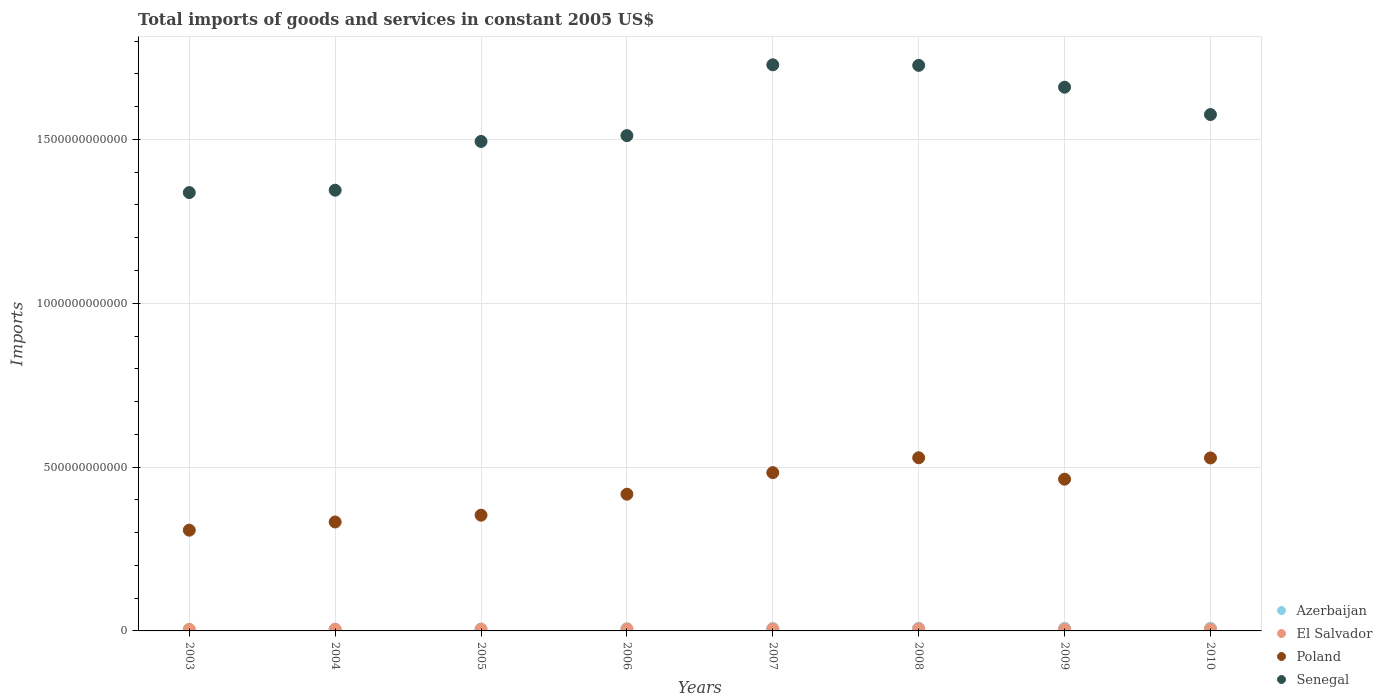How many different coloured dotlines are there?
Your answer should be compact. 4. What is the total imports of goods and services in Senegal in 2004?
Give a very brief answer. 1.35e+12. Across all years, what is the maximum total imports of goods and services in Poland?
Give a very brief answer. 5.28e+11. Across all years, what is the minimum total imports of goods and services in Senegal?
Your response must be concise. 1.34e+12. In which year was the total imports of goods and services in Senegal minimum?
Offer a very short reply. 2003. What is the total total imports of goods and services in El Salvador in the graph?
Provide a short and direct response. 4.37e+1. What is the difference between the total imports of goods and services in Poland in 2008 and that in 2010?
Make the answer very short. 5.69e+08. What is the difference between the total imports of goods and services in Azerbaijan in 2007 and the total imports of goods and services in Senegal in 2010?
Your answer should be compact. -1.57e+12. What is the average total imports of goods and services in Poland per year?
Your answer should be very brief. 4.27e+11. In the year 2007, what is the difference between the total imports of goods and services in Azerbaijan and total imports of goods and services in Senegal?
Provide a short and direct response. -1.72e+12. What is the ratio of the total imports of goods and services in El Salvador in 2007 to that in 2008?
Give a very brief answer. 0.97. Is the total imports of goods and services in Senegal in 2004 less than that in 2007?
Ensure brevity in your answer.  Yes. What is the difference between the highest and the second highest total imports of goods and services in Azerbaijan?
Make the answer very short. 3.33e+08. What is the difference between the highest and the lowest total imports of goods and services in Poland?
Offer a terse response. 2.21e+11. In how many years, is the total imports of goods and services in Poland greater than the average total imports of goods and services in Poland taken over all years?
Provide a succinct answer. 4. Is it the case that in every year, the sum of the total imports of goods and services in El Salvador and total imports of goods and services in Senegal  is greater than the sum of total imports of goods and services in Azerbaijan and total imports of goods and services in Poland?
Your answer should be very brief. No. Does the total imports of goods and services in Azerbaijan monotonically increase over the years?
Provide a short and direct response. No. Is the total imports of goods and services in El Salvador strictly greater than the total imports of goods and services in Senegal over the years?
Give a very brief answer. No. Is the total imports of goods and services in Poland strictly less than the total imports of goods and services in Senegal over the years?
Provide a short and direct response. Yes. How many dotlines are there?
Give a very brief answer. 4. How many years are there in the graph?
Give a very brief answer. 8. What is the difference between two consecutive major ticks on the Y-axis?
Your answer should be compact. 5.00e+11. Are the values on the major ticks of Y-axis written in scientific E-notation?
Ensure brevity in your answer.  No. Does the graph contain any zero values?
Provide a succinct answer. No. What is the title of the graph?
Offer a very short reply. Total imports of goods and services in constant 2005 US$. What is the label or title of the Y-axis?
Your answer should be compact. Imports. What is the Imports in Azerbaijan in 2003?
Ensure brevity in your answer.  4.22e+09. What is the Imports in El Salvador in 2003?
Give a very brief answer. 4.90e+09. What is the Imports in Poland in 2003?
Ensure brevity in your answer.  3.07e+11. What is the Imports of Senegal in 2003?
Your answer should be very brief. 1.34e+12. What is the Imports of Azerbaijan in 2004?
Provide a succinct answer. 5.25e+09. What is the Imports in El Salvador in 2004?
Your response must be concise. 5.03e+09. What is the Imports of Poland in 2004?
Keep it short and to the point. 3.32e+11. What is the Imports in Senegal in 2004?
Your answer should be compact. 1.35e+12. What is the Imports of Azerbaijan in 2005?
Provide a short and direct response. 5.74e+09. What is the Imports in El Salvador in 2005?
Your answer should be very brief. 5.24e+09. What is the Imports in Poland in 2005?
Offer a terse response. 3.53e+11. What is the Imports of Senegal in 2005?
Your response must be concise. 1.49e+12. What is the Imports of Azerbaijan in 2006?
Offer a very short reply. 6.59e+09. What is the Imports of El Salvador in 2006?
Keep it short and to the point. 5.71e+09. What is the Imports of Poland in 2006?
Your answer should be very brief. 4.17e+11. What is the Imports of Senegal in 2006?
Offer a very short reply. 1.51e+12. What is the Imports in Azerbaijan in 2007?
Your response must be concise. 7.29e+09. What is the Imports of El Salvador in 2007?
Provide a short and direct response. 6.21e+09. What is the Imports in Poland in 2007?
Offer a very short reply. 4.83e+11. What is the Imports of Senegal in 2007?
Give a very brief answer. 1.73e+12. What is the Imports of Azerbaijan in 2008?
Provide a succinct answer. 8.33e+09. What is the Imports of El Salvador in 2008?
Your answer should be very brief. 6.42e+09. What is the Imports in Poland in 2008?
Your answer should be very brief. 5.28e+11. What is the Imports of Senegal in 2008?
Offer a terse response. 1.73e+12. What is the Imports in Azerbaijan in 2009?
Provide a succinct answer. 7.89e+09. What is the Imports in El Salvador in 2009?
Your response must be concise. 4.83e+09. What is the Imports of Poland in 2009?
Your answer should be very brief. 4.63e+11. What is the Imports in Senegal in 2009?
Provide a succinct answer. 1.66e+12. What is the Imports of Azerbaijan in 2010?
Provide a short and direct response. 8.00e+09. What is the Imports of El Salvador in 2010?
Ensure brevity in your answer.  5.33e+09. What is the Imports of Poland in 2010?
Make the answer very short. 5.28e+11. What is the Imports of Senegal in 2010?
Your answer should be very brief. 1.58e+12. Across all years, what is the maximum Imports in Azerbaijan?
Your response must be concise. 8.33e+09. Across all years, what is the maximum Imports of El Salvador?
Your answer should be compact. 6.42e+09. Across all years, what is the maximum Imports in Poland?
Ensure brevity in your answer.  5.28e+11. Across all years, what is the maximum Imports in Senegal?
Provide a succinct answer. 1.73e+12. Across all years, what is the minimum Imports of Azerbaijan?
Keep it short and to the point. 4.22e+09. Across all years, what is the minimum Imports in El Salvador?
Offer a very short reply. 4.83e+09. Across all years, what is the minimum Imports of Poland?
Your response must be concise. 3.07e+11. Across all years, what is the minimum Imports of Senegal?
Your response must be concise. 1.34e+12. What is the total Imports in Azerbaijan in the graph?
Offer a very short reply. 5.33e+1. What is the total Imports in El Salvador in the graph?
Your answer should be compact. 4.37e+1. What is the total Imports in Poland in the graph?
Offer a very short reply. 3.41e+12. What is the total Imports in Senegal in the graph?
Ensure brevity in your answer.  1.24e+13. What is the difference between the Imports in Azerbaijan in 2003 and that in 2004?
Make the answer very short. -1.02e+09. What is the difference between the Imports in El Salvador in 2003 and that in 2004?
Your answer should be compact. -1.27e+08. What is the difference between the Imports of Poland in 2003 and that in 2004?
Offer a terse response. -2.50e+1. What is the difference between the Imports of Senegal in 2003 and that in 2004?
Provide a short and direct response. -7.19e+09. What is the difference between the Imports of Azerbaijan in 2003 and that in 2005?
Your answer should be compact. -1.52e+09. What is the difference between the Imports of El Salvador in 2003 and that in 2005?
Keep it short and to the point. -3.45e+08. What is the difference between the Imports in Poland in 2003 and that in 2005?
Offer a very short reply. -4.58e+1. What is the difference between the Imports of Senegal in 2003 and that in 2005?
Provide a short and direct response. -1.56e+11. What is the difference between the Imports of Azerbaijan in 2003 and that in 2006?
Give a very brief answer. -2.37e+09. What is the difference between the Imports of El Salvador in 2003 and that in 2006?
Ensure brevity in your answer.  -8.12e+08. What is the difference between the Imports of Poland in 2003 and that in 2006?
Your answer should be very brief. -1.10e+11. What is the difference between the Imports of Senegal in 2003 and that in 2006?
Give a very brief answer. -1.74e+11. What is the difference between the Imports of Azerbaijan in 2003 and that in 2007?
Your answer should be compact. -3.07e+09. What is the difference between the Imports in El Salvador in 2003 and that in 2007?
Give a very brief answer. -1.32e+09. What is the difference between the Imports in Poland in 2003 and that in 2007?
Your answer should be very brief. -1.76e+11. What is the difference between the Imports in Senegal in 2003 and that in 2007?
Offer a very short reply. -3.90e+11. What is the difference between the Imports of Azerbaijan in 2003 and that in 2008?
Give a very brief answer. -4.11e+09. What is the difference between the Imports of El Salvador in 2003 and that in 2008?
Offer a very short reply. -1.52e+09. What is the difference between the Imports of Poland in 2003 and that in 2008?
Offer a terse response. -2.21e+11. What is the difference between the Imports of Senegal in 2003 and that in 2008?
Your answer should be compact. -3.88e+11. What is the difference between the Imports of Azerbaijan in 2003 and that in 2009?
Keep it short and to the point. -3.67e+09. What is the difference between the Imports in El Salvador in 2003 and that in 2009?
Provide a succinct answer. 7.39e+07. What is the difference between the Imports in Poland in 2003 and that in 2009?
Ensure brevity in your answer.  -1.56e+11. What is the difference between the Imports of Senegal in 2003 and that in 2009?
Give a very brief answer. -3.22e+11. What is the difference between the Imports in Azerbaijan in 2003 and that in 2010?
Make the answer very short. -3.78e+09. What is the difference between the Imports of El Salvador in 2003 and that in 2010?
Provide a short and direct response. -4.29e+08. What is the difference between the Imports in Poland in 2003 and that in 2010?
Provide a succinct answer. -2.20e+11. What is the difference between the Imports of Senegal in 2003 and that in 2010?
Your answer should be very brief. -2.38e+11. What is the difference between the Imports in Azerbaijan in 2004 and that in 2005?
Your answer should be very brief. -4.96e+08. What is the difference between the Imports of El Salvador in 2004 and that in 2005?
Your answer should be very brief. -2.18e+08. What is the difference between the Imports of Poland in 2004 and that in 2005?
Give a very brief answer. -2.08e+1. What is the difference between the Imports in Senegal in 2004 and that in 2005?
Give a very brief answer. -1.49e+11. What is the difference between the Imports in Azerbaijan in 2004 and that in 2006?
Keep it short and to the point. -1.34e+09. What is the difference between the Imports of El Salvador in 2004 and that in 2006?
Your response must be concise. -6.86e+08. What is the difference between the Imports of Poland in 2004 and that in 2006?
Your answer should be compact. -8.48e+1. What is the difference between the Imports of Senegal in 2004 and that in 2006?
Provide a succinct answer. -1.67e+11. What is the difference between the Imports of Azerbaijan in 2004 and that in 2007?
Give a very brief answer. -2.04e+09. What is the difference between the Imports in El Salvador in 2004 and that in 2007?
Offer a terse response. -1.19e+09. What is the difference between the Imports in Poland in 2004 and that in 2007?
Give a very brief answer. -1.51e+11. What is the difference between the Imports of Senegal in 2004 and that in 2007?
Your answer should be very brief. -3.83e+11. What is the difference between the Imports of Azerbaijan in 2004 and that in 2008?
Provide a succinct answer. -3.09e+09. What is the difference between the Imports of El Salvador in 2004 and that in 2008?
Provide a short and direct response. -1.39e+09. What is the difference between the Imports in Poland in 2004 and that in 2008?
Provide a succinct answer. -1.96e+11. What is the difference between the Imports of Senegal in 2004 and that in 2008?
Ensure brevity in your answer.  -3.81e+11. What is the difference between the Imports of Azerbaijan in 2004 and that in 2009?
Your answer should be compact. -2.65e+09. What is the difference between the Imports of El Salvador in 2004 and that in 2009?
Offer a very short reply. 2.01e+08. What is the difference between the Imports in Poland in 2004 and that in 2009?
Your response must be concise. -1.31e+11. What is the difference between the Imports of Senegal in 2004 and that in 2009?
Offer a terse response. -3.14e+11. What is the difference between the Imports in Azerbaijan in 2004 and that in 2010?
Your answer should be very brief. -2.76e+09. What is the difference between the Imports of El Salvador in 2004 and that in 2010?
Offer a terse response. -3.02e+08. What is the difference between the Imports of Poland in 2004 and that in 2010?
Make the answer very short. -1.95e+11. What is the difference between the Imports of Senegal in 2004 and that in 2010?
Keep it short and to the point. -2.31e+11. What is the difference between the Imports in Azerbaijan in 2005 and that in 2006?
Provide a short and direct response. -8.46e+08. What is the difference between the Imports in El Salvador in 2005 and that in 2006?
Make the answer very short. -4.68e+08. What is the difference between the Imports of Poland in 2005 and that in 2006?
Your answer should be very brief. -6.40e+1. What is the difference between the Imports in Senegal in 2005 and that in 2006?
Your answer should be compact. -1.78e+1. What is the difference between the Imports in Azerbaijan in 2005 and that in 2007?
Your answer should be very brief. -1.55e+09. What is the difference between the Imports of El Salvador in 2005 and that in 2007?
Offer a terse response. -9.70e+08. What is the difference between the Imports of Poland in 2005 and that in 2007?
Your answer should be very brief. -1.30e+11. What is the difference between the Imports of Senegal in 2005 and that in 2007?
Ensure brevity in your answer.  -2.34e+11. What is the difference between the Imports in Azerbaijan in 2005 and that in 2008?
Keep it short and to the point. -2.59e+09. What is the difference between the Imports in El Salvador in 2005 and that in 2008?
Your response must be concise. -1.17e+09. What is the difference between the Imports of Poland in 2005 and that in 2008?
Offer a terse response. -1.75e+11. What is the difference between the Imports of Senegal in 2005 and that in 2008?
Offer a very short reply. -2.32e+11. What is the difference between the Imports of Azerbaijan in 2005 and that in 2009?
Your answer should be very brief. -2.15e+09. What is the difference between the Imports in El Salvador in 2005 and that in 2009?
Your answer should be compact. 4.19e+08. What is the difference between the Imports in Poland in 2005 and that in 2009?
Provide a short and direct response. -1.10e+11. What is the difference between the Imports in Senegal in 2005 and that in 2009?
Make the answer very short. -1.66e+11. What is the difference between the Imports of Azerbaijan in 2005 and that in 2010?
Make the answer very short. -2.26e+09. What is the difference between the Imports in El Salvador in 2005 and that in 2010?
Your response must be concise. -8.42e+07. What is the difference between the Imports in Poland in 2005 and that in 2010?
Your answer should be very brief. -1.75e+11. What is the difference between the Imports in Senegal in 2005 and that in 2010?
Offer a very short reply. -8.21e+1. What is the difference between the Imports of Azerbaijan in 2006 and that in 2007?
Provide a succinct answer. -7.02e+08. What is the difference between the Imports of El Salvador in 2006 and that in 2007?
Provide a succinct answer. -5.03e+08. What is the difference between the Imports of Poland in 2006 and that in 2007?
Your answer should be compact. -6.59e+1. What is the difference between the Imports of Senegal in 2006 and that in 2007?
Give a very brief answer. -2.16e+11. What is the difference between the Imports of Azerbaijan in 2006 and that in 2008?
Offer a very short reply. -1.75e+09. What is the difference between the Imports in El Salvador in 2006 and that in 2008?
Keep it short and to the point. -7.07e+08. What is the difference between the Imports in Poland in 2006 and that in 2008?
Make the answer very short. -1.11e+11. What is the difference between the Imports in Senegal in 2006 and that in 2008?
Offer a terse response. -2.14e+11. What is the difference between the Imports in Azerbaijan in 2006 and that in 2009?
Offer a very short reply. -1.31e+09. What is the difference between the Imports in El Salvador in 2006 and that in 2009?
Provide a succinct answer. 8.86e+08. What is the difference between the Imports of Poland in 2006 and that in 2009?
Offer a very short reply. -4.58e+1. What is the difference between the Imports in Senegal in 2006 and that in 2009?
Provide a short and direct response. -1.48e+11. What is the difference between the Imports of Azerbaijan in 2006 and that in 2010?
Your answer should be compact. -1.41e+09. What is the difference between the Imports of El Salvador in 2006 and that in 2010?
Give a very brief answer. 3.83e+08. What is the difference between the Imports in Poland in 2006 and that in 2010?
Your response must be concise. -1.11e+11. What is the difference between the Imports in Senegal in 2006 and that in 2010?
Make the answer very short. -6.43e+1. What is the difference between the Imports of Azerbaijan in 2007 and that in 2008?
Your answer should be very brief. -1.04e+09. What is the difference between the Imports in El Salvador in 2007 and that in 2008?
Your answer should be compact. -2.04e+08. What is the difference between the Imports of Poland in 2007 and that in 2008?
Provide a short and direct response. -4.53e+1. What is the difference between the Imports in Senegal in 2007 and that in 2008?
Your answer should be very brief. 1.72e+09. What is the difference between the Imports in Azerbaijan in 2007 and that in 2009?
Give a very brief answer. -6.05e+08. What is the difference between the Imports in El Salvador in 2007 and that in 2009?
Your answer should be very brief. 1.39e+09. What is the difference between the Imports in Poland in 2007 and that in 2009?
Your response must be concise. 2.01e+1. What is the difference between the Imports in Senegal in 2007 and that in 2009?
Ensure brevity in your answer.  6.83e+1. What is the difference between the Imports in Azerbaijan in 2007 and that in 2010?
Provide a succinct answer. -7.11e+08. What is the difference between the Imports in El Salvador in 2007 and that in 2010?
Your response must be concise. 8.86e+08. What is the difference between the Imports of Poland in 2007 and that in 2010?
Your response must be concise. -4.48e+1. What is the difference between the Imports in Senegal in 2007 and that in 2010?
Provide a short and direct response. 1.52e+11. What is the difference between the Imports of Azerbaijan in 2008 and that in 2009?
Ensure brevity in your answer.  4.40e+08. What is the difference between the Imports in El Salvador in 2008 and that in 2009?
Your answer should be very brief. 1.59e+09. What is the difference between the Imports in Poland in 2008 and that in 2009?
Ensure brevity in your answer.  6.54e+1. What is the difference between the Imports of Senegal in 2008 and that in 2009?
Provide a short and direct response. 6.66e+1. What is the difference between the Imports in Azerbaijan in 2008 and that in 2010?
Your response must be concise. 3.33e+08. What is the difference between the Imports in El Salvador in 2008 and that in 2010?
Your answer should be very brief. 1.09e+09. What is the difference between the Imports in Poland in 2008 and that in 2010?
Keep it short and to the point. 5.69e+08. What is the difference between the Imports in Senegal in 2008 and that in 2010?
Keep it short and to the point. 1.50e+11. What is the difference between the Imports of Azerbaijan in 2009 and that in 2010?
Your answer should be very brief. -1.06e+08. What is the difference between the Imports of El Salvador in 2009 and that in 2010?
Give a very brief answer. -5.03e+08. What is the difference between the Imports of Poland in 2009 and that in 2010?
Provide a succinct answer. -6.49e+1. What is the difference between the Imports in Senegal in 2009 and that in 2010?
Give a very brief answer. 8.35e+1. What is the difference between the Imports of Azerbaijan in 2003 and the Imports of El Salvador in 2004?
Offer a very short reply. -8.05e+08. What is the difference between the Imports in Azerbaijan in 2003 and the Imports in Poland in 2004?
Provide a succinct answer. -3.28e+11. What is the difference between the Imports of Azerbaijan in 2003 and the Imports of Senegal in 2004?
Provide a short and direct response. -1.34e+12. What is the difference between the Imports of El Salvador in 2003 and the Imports of Poland in 2004?
Your answer should be compact. -3.28e+11. What is the difference between the Imports of El Salvador in 2003 and the Imports of Senegal in 2004?
Give a very brief answer. -1.34e+12. What is the difference between the Imports in Poland in 2003 and the Imports in Senegal in 2004?
Ensure brevity in your answer.  -1.04e+12. What is the difference between the Imports of Azerbaijan in 2003 and the Imports of El Salvador in 2005?
Your response must be concise. -1.02e+09. What is the difference between the Imports in Azerbaijan in 2003 and the Imports in Poland in 2005?
Ensure brevity in your answer.  -3.49e+11. What is the difference between the Imports in Azerbaijan in 2003 and the Imports in Senegal in 2005?
Your answer should be compact. -1.49e+12. What is the difference between the Imports of El Salvador in 2003 and the Imports of Poland in 2005?
Offer a very short reply. -3.48e+11. What is the difference between the Imports of El Salvador in 2003 and the Imports of Senegal in 2005?
Offer a terse response. -1.49e+12. What is the difference between the Imports in Poland in 2003 and the Imports in Senegal in 2005?
Provide a succinct answer. -1.19e+12. What is the difference between the Imports of Azerbaijan in 2003 and the Imports of El Salvador in 2006?
Offer a terse response. -1.49e+09. What is the difference between the Imports in Azerbaijan in 2003 and the Imports in Poland in 2006?
Give a very brief answer. -4.13e+11. What is the difference between the Imports of Azerbaijan in 2003 and the Imports of Senegal in 2006?
Offer a very short reply. -1.51e+12. What is the difference between the Imports in El Salvador in 2003 and the Imports in Poland in 2006?
Your answer should be compact. -4.12e+11. What is the difference between the Imports in El Salvador in 2003 and the Imports in Senegal in 2006?
Keep it short and to the point. -1.51e+12. What is the difference between the Imports in Poland in 2003 and the Imports in Senegal in 2006?
Make the answer very short. -1.20e+12. What is the difference between the Imports in Azerbaijan in 2003 and the Imports in El Salvador in 2007?
Your response must be concise. -1.99e+09. What is the difference between the Imports in Azerbaijan in 2003 and the Imports in Poland in 2007?
Your answer should be very brief. -4.79e+11. What is the difference between the Imports in Azerbaijan in 2003 and the Imports in Senegal in 2007?
Make the answer very short. -1.72e+12. What is the difference between the Imports in El Salvador in 2003 and the Imports in Poland in 2007?
Provide a succinct answer. -4.78e+11. What is the difference between the Imports of El Salvador in 2003 and the Imports of Senegal in 2007?
Offer a terse response. -1.72e+12. What is the difference between the Imports of Poland in 2003 and the Imports of Senegal in 2007?
Give a very brief answer. -1.42e+12. What is the difference between the Imports of Azerbaijan in 2003 and the Imports of El Salvador in 2008?
Offer a very short reply. -2.20e+09. What is the difference between the Imports of Azerbaijan in 2003 and the Imports of Poland in 2008?
Ensure brevity in your answer.  -5.24e+11. What is the difference between the Imports of Azerbaijan in 2003 and the Imports of Senegal in 2008?
Your answer should be very brief. -1.72e+12. What is the difference between the Imports of El Salvador in 2003 and the Imports of Poland in 2008?
Give a very brief answer. -5.24e+11. What is the difference between the Imports of El Salvador in 2003 and the Imports of Senegal in 2008?
Offer a terse response. -1.72e+12. What is the difference between the Imports in Poland in 2003 and the Imports in Senegal in 2008?
Provide a succinct answer. -1.42e+12. What is the difference between the Imports of Azerbaijan in 2003 and the Imports of El Salvador in 2009?
Ensure brevity in your answer.  -6.04e+08. What is the difference between the Imports of Azerbaijan in 2003 and the Imports of Poland in 2009?
Provide a short and direct response. -4.59e+11. What is the difference between the Imports in Azerbaijan in 2003 and the Imports in Senegal in 2009?
Offer a terse response. -1.66e+12. What is the difference between the Imports of El Salvador in 2003 and the Imports of Poland in 2009?
Offer a very short reply. -4.58e+11. What is the difference between the Imports of El Salvador in 2003 and the Imports of Senegal in 2009?
Offer a terse response. -1.65e+12. What is the difference between the Imports of Poland in 2003 and the Imports of Senegal in 2009?
Your answer should be compact. -1.35e+12. What is the difference between the Imports in Azerbaijan in 2003 and the Imports in El Salvador in 2010?
Give a very brief answer. -1.11e+09. What is the difference between the Imports in Azerbaijan in 2003 and the Imports in Poland in 2010?
Provide a short and direct response. -5.24e+11. What is the difference between the Imports in Azerbaijan in 2003 and the Imports in Senegal in 2010?
Your answer should be very brief. -1.57e+12. What is the difference between the Imports in El Salvador in 2003 and the Imports in Poland in 2010?
Keep it short and to the point. -5.23e+11. What is the difference between the Imports in El Salvador in 2003 and the Imports in Senegal in 2010?
Offer a terse response. -1.57e+12. What is the difference between the Imports in Poland in 2003 and the Imports in Senegal in 2010?
Keep it short and to the point. -1.27e+12. What is the difference between the Imports in Azerbaijan in 2004 and the Imports in El Salvador in 2005?
Give a very brief answer. 1.32e+06. What is the difference between the Imports in Azerbaijan in 2004 and the Imports in Poland in 2005?
Your response must be concise. -3.48e+11. What is the difference between the Imports in Azerbaijan in 2004 and the Imports in Senegal in 2005?
Offer a very short reply. -1.49e+12. What is the difference between the Imports in El Salvador in 2004 and the Imports in Poland in 2005?
Provide a short and direct response. -3.48e+11. What is the difference between the Imports of El Salvador in 2004 and the Imports of Senegal in 2005?
Your response must be concise. -1.49e+12. What is the difference between the Imports in Poland in 2004 and the Imports in Senegal in 2005?
Offer a terse response. -1.16e+12. What is the difference between the Imports of Azerbaijan in 2004 and the Imports of El Salvador in 2006?
Offer a very short reply. -4.66e+08. What is the difference between the Imports of Azerbaijan in 2004 and the Imports of Poland in 2006?
Your answer should be compact. -4.12e+11. What is the difference between the Imports of Azerbaijan in 2004 and the Imports of Senegal in 2006?
Your answer should be very brief. -1.51e+12. What is the difference between the Imports of El Salvador in 2004 and the Imports of Poland in 2006?
Give a very brief answer. -4.12e+11. What is the difference between the Imports of El Salvador in 2004 and the Imports of Senegal in 2006?
Your answer should be very brief. -1.51e+12. What is the difference between the Imports in Poland in 2004 and the Imports in Senegal in 2006?
Make the answer very short. -1.18e+12. What is the difference between the Imports in Azerbaijan in 2004 and the Imports in El Salvador in 2007?
Your answer should be compact. -9.69e+08. What is the difference between the Imports of Azerbaijan in 2004 and the Imports of Poland in 2007?
Offer a terse response. -4.78e+11. What is the difference between the Imports in Azerbaijan in 2004 and the Imports in Senegal in 2007?
Keep it short and to the point. -1.72e+12. What is the difference between the Imports in El Salvador in 2004 and the Imports in Poland in 2007?
Keep it short and to the point. -4.78e+11. What is the difference between the Imports in El Salvador in 2004 and the Imports in Senegal in 2007?
Provide a short and direct response. -1.72e+12. What is the difference between the Imports of Poland in 2004 and the Imports of Senegal in 2007?
Provide a succinct answer. -1.40e+12. What is the difference between the Imports in Azerbaijan in 2004 and the Imports in El Salvador in 2008?
Make the answer very short. -1.17e+09. What is the difference between the Imports of Azerbaijan in 2004 and the Imports of Poland in 2008?
Provide a short and direct response. -5.23e+11. What is the difference between the Imports in Azerbaijan in 2004 and the Imports in Senegal in 2008?
Give a very brief answer. -1.72e+12. What is the difference between the Imports in El Salvador in 2004 and the Imports in Poland in 2008?
Your response must be concise. -5.23e+11. What is the difference between the Imports in El Salvador in 2004 and the Imports in Senegal in 2008?
Provide a succinct answer. -1.72e+12. What is the difference between the Imports of Poland in 2004 and the Imports of Senegal in 2008?
Keep it short and to the point. -1.39e+12. What is the difference between the Imports of Azerbaijan in 2004 and the Imports of El Salvador in 2009?
Provide a short and direct response. 4.20e+08. What is the difference between the Imports of Azerbaijan in 2004 and the Imports of Poland in 2009?
Provide a short and direct response. -4.58e+11. What is the difference between the Imports of Azerbaijan in 2004 and the Imports of Senegal in 2009?
Your response must be concise. -1.65e+12. What is the difference between the Imports of El Salvador in 2004 and the Imports of Poland in 2009?
Your answer should be compact. -4.58e+11. What is the difference between the Imports of El Salvador in 2004 and the Imports of Senegal in 2009?
Ensure brevity in your answer.  -1.65e+12. What is the difference between the Imports of Poland in 2004 and the Imports of Senegal in 2009?
Your response must be concise. -1.33e+12. What is the difference between the Imports of Azerbaijan in 2004 and the Imports of El Salvador in 2010?
Your answer should be very brief. -8.29e+07. What is the difference between the Imports of Azerbaijan in 2004 and the Imports of Poland in 2010?
Make the answer very short. -5.23e+11. What is the difference between the Imports of Azerbaijan in 2004 and the Imports of Senegal in 2010?
Ensure brevity in your answer.  -1.57e+12. What is the difference between the Imports of El Salvador in 2004 and the Imports of Poland in 2010?
Make the answer very short. -5.23e+11. What is the difference between the Imports in El Salvador in 2004 and the Imports in Senegal in 2010?
Ensure brevity in your answer.  -1.57e+12. What is the difference between the Imports in Poland in 2004 and the Imports in Senegal in 2010?
Provide a succinct answer. -1.24e+12. What is the difference between the Imports in Azerbaijan in 2005 and the Imports in El Salvador in 2006?
Give a very brief answer. 3.03e+07. What is the difference between the Imports in Azerbaijan in 2005 and the Imports in Poland in 2006?
Provide a short and direct response. -4.12e+11. What is the difference between the Imports of Azerbaijan in 2005 and the Imports of Senegal in 2006?
Provide a succinct answer. -1.51e+12. What is the difference between the Imports of El Salvador in 2005 and the Imports of Poland in 2006?
Make the answer very short. -4.12e+11. What is the difference between the Imports of El Salvador in 2005 and the Imports of Senegal in 2006?
Ensure brevity in your answer.  -1.51e+12. What is the difference between the Imports in Poland in 2005 and the Imports in Senegal in 2006?
Offer a very short reply. -1.16e+12. What is the difference between the Imports of Azerbaijan in 2005 and the Imports of El Salvador in 2007?
Your response must be concise. -4.73e+08. What is the difference between the Imports of Azerbaijan in 2005 and the Imports of Poland in 2007?
Provide a short and direct response. -4.77e+11. What is the difference between the Imports in Azerbaijan in 2005 and the Imports in Senegal in 2007?
Offer a terse response. -1.72e+12. What is the difference between the Imports of El Salvador in 2005 and the Imports of Poland in 2007?
Give a very brief answer. -4.78e+11. What is the difference between the Imports of El Salvador in 2005 and the Imports of Senegal in 2007?
Offer a very short reply. -1.72e+12. What is the difference between the Imports in Poland in 2005 and the Imports in Senegal in 2007?
Your answer should be compact. -1.37e+12. What is the difference between the Imports of Azerbaijan in 2005 and the Imports of El Salvador in 2008?
Provide a short and direct response. -6.77e+08. What is the difference between the Imports of Azerbaijan in 2005 and the Imports of Poland in 2008?
Offer a very short reply. -5.23e+11. What is the difference between the Imports in Azerbaijan in 2005 and the Imports in Senegal in 2008?
Ensure brevity in your answer.  -1.72e+12. What is the difference between the Imports in El Salvador in 2005 and the Imports in Poland in 2008?
Provide a succinct answer. -5.23e+11. What is the difference between the Imports in El Salvador in 2005 and the Imports in Senegal in 2008?
Your response must be concise. -1.72e+12. What is the difference between the Imports in Poland in 2005 and the Imports in Senegal in 2008?
Give a very brief answer. -1.37e+12. What is the difference between the Imports in Azerbaijan in 2005 and the Imports in El Salvador in 2009?
Your answer should be compact. 9.17e+08. What is the difference between the Imports of Azerbaijan in 2005 and the Imports of Poland in 2009?
Your answer should be compact. -4.57e+11. What is the difference between the Imports in Azerbaijan in 2005 and the Imports in Senegal in 2009?
Offer a very short reply. -1.65e+12. What is the difference between the Imports of El Salvador in 2005 and the Imports of Poland in 2009?
Give a very brief answer. -4.58e+11. What is the difference between the Imports in El Salvador in 2005 and the Imports in Senegal in 2009?
Your answer should be very brief. -1.65e+12. What is the difference between the Imports in Poland in 2005 and the Imports in Senegal in 2009?
Ensure brevity in your answer.  -1.31e+12. What is the difference between the Imports in Azerbaijan in 2005 and the Imports in El Salvador in 2010?
Your response must be concise. 4.14e+08. What is the difference between the Imports in Azerbaijan in 2005 and the Imports in Poland in 2010?
Offer a very short reply. -5.22e+11. What is the difference between the Imports of Azerbaijan in 2005 and the Imports of Senegal in 2010?
Your answer should be compact. -1.57e+12. What is the difference between the Imports in El Salvador in 2005 and the Imports in Poland in 2010?
Provide a succinct answer. -5.23e+11. What is the difference between the Imports in El Salvador in 2005 and the Imports in Senegal in 2010?
Offer a very short reply. -1.57e+12. What is the difference between the Imports in Poland in 2005 and the Imports in Senegal in 2010?
Provide a short and direct response. -1.22e+12. What is the difference between the Imports in Azerbaijan in 2006 and the Imports in El Salvador in 2007?
Your answer should be very brief. 3.73e+08. What is the difference between the Imports in Azerbaijan in 2006 and the Imports in Poland in 2007?
Your response must be concise. -4.77e+11. What is the difference between the Imports of Azerbaijan in 2006 and the Imports of Senegal in 2007?
Ensure brevity in your answer.  -1.72e+12. What is the difference between the Imports in El Salvador in 2006 and the Imports in Poland in 2007?
Keep it short and to the point. -4.77e+11. What is the difference between the Imports in El Salvador in 2006 and the Imports in Senegal in 2007?
Give a very brief answer. -1.72e+12. What is the difference between the Imports in Poland in 2006 and the Imports in Senegal in 2007?
Keep it short and to the point. -1.31e+12. What is the difference between the Imports in Azerbaijan in 2006 and the Imports in El Salvador in 2008?
Provide a short and direct response. 1.69e+08. What is the difference between the Imports in Azerbaijan in 2006 and the Imports in Poland in 2008?
Provide a succinct answer. -5.22e+11. What is the difference between the Imports of Azerbaijan in 2006 and the Imports of Senegal in 2008?
Give a very brief answer. -1.72e+12. What is the difference between the Imports in El Salvador in 2006 and the Imports in Poland in 2008?
Ensure brevity in your answer.  -5.23e+11. What is the difference between the Imports in El Salvador in 2006 and the Imports in Senegal in 2008?
Offer a very short reply. -1.72e+12. What is the difference between the Imports in Poland in 2006 and the Imports in Senegal in 2008?
Keep it short and to the point. -1.31e+12. What is the difference between the Imports in Azerbaijan in 2006 and the Imports in El Salvador in 2009?
Your answer should be compact. 1.76e+09. What is the difference between the Imports in Azerbaijan in 2006 and the Imports in Poland in 2009?
Provide a succinct answer. -4.56e+11. What is the difference between the Imports in Azerbaijan in 2006 and the Imports in Senegal in 2009?
Offer a very short reply. -1.65e+12. What is the difference between the Imports of El Salvador in 2006 and the Imports of Poland in 2009?
Your answer should be compact. -4.57e+11. What is the difference between the Imports in El Salvador in 2006 and the Imports in Senegal in 2009?
Provide a succinct answer. -1.65e+12. What is the difference between the Imports in Poland in 2006 and the Imports in Senegal in 2009?
Offer a very short reply. -1.24e+12. What is the difference between the Imports of Azerbaijan in 2006 and the Imports of El Salvador in 2010?
Your answer should be compact. 1.26e+09. What is the difference between the Imports in Azerbaijan in 2006 and the Imports in Poland in 2010?
Keep it short and to the point. -5.21e+11. What is the difference between the Imports of Azerbaijan in 2006 and the Imports of Senegal in 2010?
Provide a short and direct response. -1.57e+12. What is the difference between the Imports of El Salvador in 2006 and the Imports of Poland in 2010?
Your response must be concise. -5.22e+11. What is the difference between the Imports of El Salvador in 2006 and the Imports of Senegal in 2010?
Your answer should be very brief. -1.57e+12. What is the difference between the Imports in Poland in 2006 and the Imports in Senegal in 2010?
Your response must be concise. -1.16e+12. What is the difference between the Imports of Azerbaijan in 2007 and the Imports of El Salvador in 2008?
Provide a succinct answer. 8.71e+08. What is the difference between the Imports of Azerbaijan in 2007 and the Imports of Poland in 2008?
Offer a very short reply. -5.21e+11. What is the difference between the Imports in Azerbaijan in 2007 and the Imports in Senegal in 2008?
Make the answer very short. -1.72e+12. What is the difference between the Imports in El Salvador in 2007 and the Imports in Poland in 2008?
Offer a very short reply. -5.22e+11. What is the difference between the Imports in El Salvador in 2007 and the Imports in Senegal in 2008?
Provide a succinct answer. -1.72e+12. What is the difference between the Imports of Poland in 2007 and the Imports of Senegal in 2008?
Your answer should be compact. -1.24e+12. What is the difference between the Imports in Azerbaijan in 2007 and the Imports in El Salvador in 2009?
Your answer should be compact. 2.46e+09. What is the difference between the Imports of Azerbaijan in 2007 and the Imports of Poland in 2009?
Offer a very short reply. -4.56e+11. What is the difference between the Imports of Azerbaijan in 2007 and the Imports of Senegal in 2009?
Give a very brief answer. -1.65e+12. What is the difference between the Imports in El Salvador in 2007 and the Imports in Poland in 2009?
Keep it short and to the point. -4.57e+11. What is the difference between the Imports of El Salvador in 2007 and the Imports of Senegal in 2009?
Offer a terse response. -1.65e+12. What is the difference between the Imports in Poland in 2007 and the Imports in Senegal in 2009?
Provide a succinct answer. -1.18e+12. What is the difference between the Imports of Azerbaijan in 2007 and the Imports of El Salvador in 2010?
Make the answer very short. 1.96e+09. What is the difference between the Imports of Azerbaijan in 2007 and the Imports of Poland in 2010?
Make the answer very short. -5.21e+11. What is the difference between the Imports of Azerbaijan in 2007 and the Imports of Senegal in 2010?
Your answer should be very brief. -1.57e+12. What is the difference between the Imports in El Salvador in 2007 and the Imports in Poland in 2010?
Your answer should be compact. -5.22e+11. What is the difference between the Imports in El Salvador in 2007 and the Imports in Senegal in 2010?
Your answer should be compact. -1.57e+12. What is the difference between the Imports in Poland in 2007 and the Imports in Senegal in 2010?
Give a very brief answer. -1.09e+12. What is the difference between the Imports of Azerbaijan in 2008 and the Imports of El Salvador in 2009?
Make the answer very short. 3.51e+09. What is the difference between the Imports in Azerbaijan in 2008 and the Imports in Poland in 2009?
Your answer should be compact. -4.55e+11. What is the difference between the Imports of Azerbaijan in 2008 and the Imports of Senegal in 2009?
Keep it short and to the point. -1.65e+12. What is the difference between the Imports in El Salvador in 2008 and the Imports in Poland in 2009?
Ensure brevity in your answer.  -4.57e+11. What is the difference between the Imports in El Salvador in 2008 and the Imports in Senegal in 2009?
Ensure brevity in your answer.  -1.65e+12. What is the difference between the Imports in Poland in 2008 and the Imports in Senegal in 2009?
Ensure brevity in your answer.  -1.13e+12. What is the difference between the Imports in Azerbaijan in 2008 and the Imports in El Salvador in 2010?
Provide a succinct answer. 3.01e+09. What is the difference between the Imports of Azerbaijan in 2008 and the Imports of Poland in 2010?
Offer a terse response. -5.20e+11. What is the difference between the Imports in Azerbaijan in 2008 and the Imports in Senegal in 2010?
Offer a terse response. -1.57e+12. What is the difference between the Imports in El Salvador in 2008 and the Imports in Poland in 2010?
Keep it short and to the point. -5.21e+11. What is the difference between the Imports of El Salvador in 2008 and the Imports of Senegal in 2010?
Your response must be concise. -1.57e+12. What is the difference between the Imports of Poland in 2008 and the Imports of Senegal in 2010?
Your answer should be very brief. -1.05e+12. What is the difference between the Imports in Azerbaijan in 2009 and the Imports in El Salvador in 2010?
Offer a terse response. 2.57e+09. What is the difference between the Imports in Azerbaijan in 2009 and the Imports in Poland in 2010?
Keep it short and to the point. -5.20e+11. What is the difference between the Imports of Azerbaijan in 2009 and the Imports of Senegal in 2010?
Make the answer very short. -1.57e+12. What is the difference between the Imports of El Salvador in 2009 and the Imports of Poland in 2010?
Your answer should be compact. -5.23e+11. What is the difference between the Imports of El Salvador in 2009 and the Imports of Senegal in 2010?
Give a very brief answer. -1.57e+12. What is the difference between the Imports of Poland in 2009 and the Imports of Senegal in 2010?
Your answer should be compact. -1.11e+12. What is the average Imports in Azerbaijan per year?
Offer a very short reply. 6.66e+09. What is the average Imports in El Salvador per year?
Your response must be concise. 5.46e+09. What is the average Imports of Poland per year?
Make the answer very short. 4.27e+11. What is the average Imports of Senegal per year?
Give a very brief answer. 1.55e+12. In the year 2003, what is the difference between the Imports in Azerbaijan and Imports in El Salvador?
Make the answer very short. -6.78e+08. In the year 2003, what is the difference between the Imports of Azerbaijan and Imports of Poland?
Give a very brief answer. -3.03e+11. In the year 2003, what is the difference between the Imports of Azerbaijan and Imports of Senegal?
Give a very brief answer. -1.33e+12. In the year 2003, what is the difference between the Imports of El Salvador and Imports of Poland?
Your response must be concise. -3.03e+11. In the year 2003, what is the difference between the Imports of El Salvador and Imports of Senegal?
Your answer should be compact. -1.33e+12. In the year 2003, what is the difference between the Imports of Poland and Imports of Senegal?
Offer a very short reply. -1.03e+12. In the year 2004, what is the difference between the Imports in Azerbaijan and Imports in El Salvador?
Keep it short and to the point. 2.19e+08. In the year 2004, what is the difference between the Imports in Azerbaijan and Imports in Poland?
Ensure brevity in your answer.  -3.27e+11. In the year 2004, what is the difference between the Imports of Azerbaijan and Imports of Senegal?
Ensure brevity in your answer.  -1.34e+12. In the year 2004, what is the difference between the Imports in El Salvador and Imports in Poland?
Provide a short and direct response. -3.27e+11. In the year 2004, what is the difference between the Imports of El Salvador and Imports of Senegal?
Offer a terse response. -1.34e+12. In the year 2004, what is the difference between the Imports in Poland and Imports in Senegal?
Give a very brief answer. -1.01e+12. In the year 2005, what is the difference between the Imports of Azerbaijan and Imports of El Salvador?
Offer a very short reply. 4.98e+08. In the year 2005, what is the difference between the Imports of Azerbaijan and Imports of Poland?
Keep it short and to the point. -3.48e+11. In the year 2005, what is the difference between the Imports of Azerbaijan and Imports of Senegal?
Give a very brief answer. -1.49e+12. In the year 2005, what is the difference between the Imports in El Salvador and Imports in Poland?
Your answer should be very brief. -3.48e+11. In the year 2005, what is the difference between the Imports in El Salvador and Imports in Senegal?
Make the answer very short. -1.49e+12. In the year 2005, what is the difference between the Imports of Poland and Imports of Senegal?
Offer a terse response. -1.14e+12. In the year 2006, what is the difference between the Imports in Azerbaijan and Imports in El Salvador?
Offer a terse response. 8.76e+08. In the year 2006, what is the difference between the Imports of Azerbaijan and Imports of Poland?
Make the answer very short. -4.11e+11. In the year 2006, what is the difference between the Imports of Azerbaijan and Imports of Senegal?
Offer a very short reply. -1.51e+12. In the year 2006, what is the difference between the Imports in El Salvador and Imports in Poland?
Provide a short and direct response. -4.12e+11. In the year 2006, what is the difference between the Imports of El Salvador and Imports of Senegal?
Keep it short and to the point. -1.51e+12. In the year 2006, what is the difference between the Imports in Poland and Imports in Senegal?
Your answer should be compact. -1.09e+12. In the year 2007, what is the difference between the Imports of Azerbaijan and Imports of El Salvador?
Provide a succinct answer. 1.08e+09. In the year 2007, what is the difference between the Imports in Azerbaijan and Imports in Poland?
Your answer should be very brief. -4.76e+11. In the year 2007, what is the difference between the Imports of Azerbaijan and Imports of Senegal?
Provide a short and direct response. -1.72e+12. In the year 2007, what is the difference between the Imports in El Salvador and Imports in Poland?
Offer a terse response. -4.77e+11. In the year 2007, what is the difference between the Imports of El Salvador and Imports of Senegal?
Your answer should be compact. -1.72e+12. In the year 2007, what is the difference between the Imports in Poland and Imports in Senegal?
Your response must be concise. -1.24e+12. In the year 2008, what is the difference between the Imports of Azerbaijan and Imports of El Salvador?
Provide a short and direct response. 1.92e+09. In the year 2008, what is the difference between the Imports in Azerbaijan and Imports in Poland?
Your response must be concise. -5.20e+11. In the year 2008, what is the difference between the Imports in Azerbaijan and Imports in Senegal?
Your response must be concise. -1.72e+12. In the year 2008, what is the difference between the Imports in El Salvador and Imports in Poland?
Provide a succinct answer. -5.22e+11. In the year 2008, what is the difference between the Imports of El Salvador and Imports of Senegal?
Provide a succinct answer. -1.72e+12. In the year 2008, what is the difference between the Imports of Poland and Imports of Senegal?
Make the answer very short. -1.20e+12. In the year 2009, what is the difference between the Imports of Azerbaijan and Imports of El Salvador?
Offer a terse response. 3.07e+09. In the year 2009, what is the difference between the Imports in Azerbaijan and Imports in Poland?
Ensure brevity in your answer.  -4.55e+11. In the year 2009, what is the difference between the Imports in Azerbaijan and Imports in Senegal?
Keep it short and to the point. -1.65e+12. In the year 2009, what is the difference between the Imports of El Salvador and Imports of Poland?
Give a very brief answer. -4.58e+11. In the year 2009, what is the difference between the Imports in El Salvador and Imports in Senegal?
Ensure brevity in your answer.  -1.65e+12. In the year 2009, what is the difference between the Imports of Poland and Imports of Senegal?
Keep it short and to the point. -1.20e+12. In the year 2010, what is the difference between the Imports of Azerbaijan and Imports of El Salvador?
Make the answer very short. 2.67e+09. In the year 2010, what is the difference between the Imports of Azerbaijan and Imports of Poland?
Your answer should be compact. -5.20e+11. In the year 2010, what is the difference between the Imports in Azerbaijan and Imports in Senegal?
Give a very brief answer. -1.57e+12. In the year 2010, what is the difference between the Imports in El Salvador and Imports in Poland?
Your answer should be very brief. -5.23e+11. In the year 2010, what is the difference between the Imports of El Salvador and Imports of Senegal?
Your answer should be very brief. -1.57e+12. In the year 2010, what is the difference between the Imports in Poland and Imports in Senegal?
Your answer should be compact. -1.05e+12. What is the ratio of the Imports of Azerbaijan in 2003 to that in 2004?
Your answer should be compact. 0.8. What is the ratio of the Imports in El Salvador in 2003 to that in 2004?
Offer a terse response. 0.97. What is the ratio of the Imports in Poland in 2003 to that in 2004?
Your response must be concise. 0.92. What is the ratio of the Imports in Senegal in 2003 to that in 2004?
Make the answer very short. 0.99. What is the ratio of the Imports in Azerbaijan in 2003 to that in 2005?
Make the answer very short. 0.74. What is the ratio of the Imports of El Salvador in 2003 to that in 2005?
Offer a very short reply. 0.93. What is the ratio of the Imports of Poland in 2003 to that in 2005?
Offer a terse response. 0.87. What is the ratio of the Imports in Senegal in 2003 to that in 2005?
Give a very brief answer. 0.9. What is the ratio of the Imports of Azerbaijan in 2003 to that in 2006?
Provide a succinct answer. 0.64. What is the ratio of the Imports in El Salvador in 2003 to that in 2006?
Make the answer very short. 0.86. What is the ratio of the Imports of Poland in 2003 to that in 2006?
Your answer should be very brief. 0.74. What is the ratio of the Imports of Senegal in 2003 to that in 2006?
Ensure brevity in your answer.  0.89. What is the ratio of the Imports in Azerbaijan in 2003 to that in 2007?
Offer a terse response. 0.58. What is the ratio of the Imports of El Salvador in 2003 to that in 2007?
Your answer should be very brief. 0.79. What is the ratio of the Imports of Poland in 2003 to that in 2007?
Your answer should be compact. 0.64. What is the ratio of the Imports in Senegal in 2003 to that in 2007?
Your answer should be very brief. 0.77. What is the ratio of the Imports of Azerbaijan in 2003 to that in 2008?
Offer a terse response. 0.51. What is the ratio of the Imports of El Salvador in 2003 to that in 2008?
Provide a short and direct response. 0.76. What is the ratio of the Imports in Poland in 2003 to that in 2008?
Your response must be concise. 0.58. What is the ratio of the Imports in Senegal in 2003 to that in 2008?
Make the answer very short. 0.78. What is the ratio of the Imports in Azerbaijan in 2003 to that in 2009?
Ensure brevity in your answer.  0.53. What is the ratio of the Imports of El Salvador in 2003 to that in 2009?
Your answer should be compact. 1.02. What is the ratio of the Imports of Poland in 2003 to that in 2009?
Make the answer very short. 0.66. What is the ratio of the Imports of Senegal in 2003 to that in 2009?
Your answer should be compact. 0.81. What is the ratio of the Imports in Azerbaijan in 2003 to that in 2010?
Ensure brevity in your answer.  0.53. What is the ratio of the Imports in El Salvador in 2003 to that in 2010?
Your answer should be very brief. 0.92. What is the ratio of the Imports in Poland in 2003 to that in 2010?
Give a very brief answer. 0.58. What is the ratio of the Imports of Senegal in 2003 to that in 2010?
Keep it short and to the point. 0.85. What is the ratio of the Imports of Azerbaijan in 2004 to that in 2005?
Your answer should be compact. 0.91. What is the ratio of the Imports in El Salvador in 2004 to that in 2005?
Keep it short and to the point. 0.96. What is the ratio of the Imports in Poland in 2004 to that in 2005?
Offer a very short reply. 0.94. What is the ratio of the Imports in Senegal in 2004 to that in 2005?
Provide a succinct answer. 0.9. What is the ratio of the Imports of Azerbaijan in 2004 to that in 2006?
Make the answer very short. 0.8. What is the ratio of the Imports of Poland in 2004 to that in 2006?
Your answer should be very brief. 0.8. What is the ratio of the Imports of Senegal in 2004 to that in 2006?
Give a very brief answer. 0.89. What is the ratio of the Imports of Azerbaijan in 2004 to that in 2007?
Make the answer very short. 0.72. What is the ratio of the Imports in El Salvador in 2004 to that in 2007?
Your response must be concise. 0.81. What is the ratio of the Imports in Poland in 2004 to that in 2007?
Provide a short and direct response. 0.69. What is the ratio of the Imports in Senegal in 2004 to that in 2007?
Offer a very short reply. 0.78. What is the ratio of the Imports of Azerbaijan in 2004 to that in 2008?
Ensure brevity in your answer.  0.63. What is the ratio of the Imports in El Salvador in 2004 to that in 2008?
Provide a succinct answer. 0.78. What is the ratio of the Imports of Poland in 2004 to that in 2008?
Offer a terse response. 0.63. What is the ratio of the Imports of Senegal in 2004 to that in 2008?
Your response must be concise. 0.78. What is the ratio of the Imports of Azerbaijan in 2004 to that in 2009?
Ensure brevity in your answer.  0.66. What is the ratio of the Imports in El Salvador in 2004 to that in 2009?
Give a very brief answer. 1.04. What is the ratio of the Imports in Poland in 2004 to that in 2009?
Your answer should be compact. 0.72. What is the ratio of the Imports in Senegal in 2004 to that in 2009?
Your answer should be very brief. 0.81. What is the ratio of the Imports of Azerbaijan in 2004 to that in 2010?
Offer a very short reply. 0.66. What is the ratio of the Imports of El Salvador in 2004 to that in 2010?
Your response must be concise. 0.94. What is the ratio of the Imports of Poland in 2004 to that in 2010?
Provide a succinct answer. 0.63. What is the ratio of the Imports in Senegal in 2004 to that in 2010?
Your answer should be compact. 0.85. What is the ratio of the Imports in Azerbaijan in 2005 to that in 2006?
Your response must be concise. 0.87. What is the ratio of the Imports of El Salvador in 2005 to that in 2006?
Ensure brevity in your answer.  0.92. What is the ratio of the Imports of Poland in 2005 to that in 2006?
Your response must be concise. 0.85. What is the ratio of the Imports of Senegal in 2005 to that in 2006?
Ensure brevity in your answer.  0.99. What is the ratio of the Imports in Azerbaijan in 2005 to that in 2007?
Provide a succinct answer. 0.79. What is the ratio of the Imports in El Salvador in 2005 to that in 2007?
Your response must be concise. 0.84. What is the ratio of the Imports in Poland in 2005 to that in 2007?
Your answer should be very brief. 0.73. What is the ratio of the Imports in Senegal in 2005 to that in 2007?
Make the answer very short. 0.86. What is the ratio of the Imports in Azerbaijan in 2005 to that in 2008?
Your response must be concise. 0.69. What is the ratio of the Imports in El Salvador in 2005 to that in 2008?
Give a very brief answer. 0.82. What is the ratio of the Imports in Poland in 2005 to that in 2008?
Ensure brevity in your answer.  0.67. What is the ratio of the Imports of Senegal in 2005 to that in 2008?
Provide a succinct answer. 0.87. What is the ratio of the Imports of Azerbaijan in 2005 to that in 2009?
Provide a succinct answer. 0.73. What is the ratio of the Imports in El Salvador in 2005 to that in 2009?
Give a very brief answer. 1.09. What is the ratio of the Imports of Poland in 2005 to that in 2009?
Your response must be concise. 0.76. What is the ratio of the Imports in Senegal in 2005 to that in 2009?
Provide a short and direct response. 0.9. What is the ratio of the Imports of Azerbaijan in 2005 to that in 2010?
Your answer should be very brief. 0.72. What is the ratio of the Imports of El Salvador in 2005 to that in 2010?
Your answer should be compact. 0.98. What is the ratio of the Imports of Poland in 2005 to that in 2010?
Offer a very short reply. 0.67. What is the ratio of the Imports of Senegal in 2005 to that in 2010?
Your response must be concise. 0.95. What is the ratio of the Imports in Azerbaijan in 2006 to that in 2007?
Give a very brief answer. 0.9. What is the ratio of the Imports of El Salvador in 2006 to that in 2007?
Provide a succinct answer. 0.92. What is the ratio of the Imports in Poland in 2006 to that in 2007?
Give a very brief answer. 0.86. What is the ratio of the Imports of Azerbaijan in 2006 to that in 2008?
Keep it short and to the point. 0.79. What is the ratio of the Imports of El Salvador in 2006 to that in 2008?
Keep it short and to the point. 0.89. What is the ratio of the Imports of Poland in 2006 to that in 2008?
Offer a terse response. 0.79. What is the ratio of the Imports of Senegal in 2006 to that in 2008?
Provide a short and direct response. 0.88. What is the ratio of the Imports of Azerbaijan in 2006 to that in 2009?
Your response must be concise. 0.83. What is the ratio of the Imports of El Salvador in 2006 to that in 2009?
Give a very brief answer. 1.18. What is the ratio of the Imports in Poland in 2006 to that in 2009?
Your answer should be compact. 0.9. What is the ratio of the Imports of Senegal in 2006 to that in 2009?
Ensure brevity in your answer.  0.91. What is the ratio of the Imports of Azerbaijan in 2006 to that in 2010?
Your answer should be compact. 0.82. What is the ratio of the Imports in El Salvador in 2006 to that in 2010?
Ensure brevity in your answer.  1.07. What is the ratio of the Imports of Poland in 2006 to that in 2010?
Your answer should be very brief. 0.79. What is the ratio of the Imports in Senegal in 2006 to that in 2010?
Offer a terse response. 0.96. What is the ratio of the Imports in Azerbaijan in 2007 to that in 2008?
Offer a very short reply. 0.87. What is the ratio of the Imports in El Salvador in 2007 to that in 2008?
Your response must be concise. 0.97. What is the ratio of the Imports of Poland in 2007 to that in 2008?
Offer a terse response. 0.91. What is the ratio of the Imports in Senegal in 2007 to that in 2008?
Offer a very short reply. 1. What is the ratio of the Imports of Azerbaijan in 2007 to that in 2009?
Your answer should be compact. 0.92. What is the ratio of the Imports in El Salvador in 2007 to that in 2009?
Make the answer very short. 1.29. What is the ratio of the Imports in Poland in 2007 to that in 2009?
Provide a succinct answer. 1.04. What is the ratio of the Imports of Senegal in 2007 to that in 2009?
Give a very brief answer. 1.04. What is the ratio of the Imports in Azerbaijan in 2007 to that in 2010?
Your response must be concise. 0.91. What is the ratio of the Imports of El Salvador in 2007 to that in 2010?
Provide a succinct answer. 1.17. What is the ratio of the Imports of Poland in 2007 to that in 2010?
Your answer should be very brief. 0.92. What is the ratio of the Imports in Senegal in 2007 to that in 2010?
Offer a terse response. 1.1. What is the ratio of the Imports in Azerbaijan in 2008 to that in 2009?
Provide a succinct answer. 1.06. What is the ratio of the Imports in El Salvador in 2008 to that in 2009?
Make the answer very short. 1.33. What is the ratio of the Imports of Poland in 2008 to that in 2009?
Keep it short and to the point. 1.14. What is the ratio of the Imports of Senegal in 2008 to that in 2009?
Offer a terse response. 1.04. What is the ratio of the Imports of Azerbaijan in 2008 to that in 2010?
Your answer should be very brief. 1.04. What is the ratio of the Imports of El Salvador in 2008 to that in 2010?
Make the answer very short. 1.2. What is the ratio of the Imports of Poland in 2008 to that in 2010?
Ensure brevity in your answer.  1. What is the ratio of the Imports of Senegal in 2008 to that in 2010?
Make the answer very short. 1.1. What is the ratio of the Imports in Azerbaijan in 2009 to that in 2010?
Keep it short and to the point. 0.99. What is the ratio of the Imports of El Salvador in 2009 to that in 2010?
Give a very brief answer. 0.91. What is the ratio of the Imports of Poland in 2009 to that in 2010?
Ensure brevity in your answer.  0.88. What is the ratio of the Imports in Senegal in 2009 to that in 2010?
Your answer should be very brief. 1.05. What is the difference between the highest and the second highest Imports in Azerbaijan?
Your answer should be very brief. 3.33e+08. What is the difference between the highest and the second highest Imports of El Salvador?
Provide a short and direct response. 2.04e+08. What is the difference between the highest and the second highest Imports in Poland?
Offer a very short reply. 5.69e+08. What is the difference between the highest and the second highest Imports in Senegal?
Ensure brevity in your answer.  1.72e+09. What is the difference between the highest and the lowest Imports in Azerbaijan?
Your response must be concise. 4.11e+09. What is the difference between the highest and the lowest Imports of El Salvador?
Offer a terse response. 1.59e+09. What is the difference between the highest and the lowest Imports in Poland?
Your answer should be compact. 2.21e+11. What is the difference between the highest and the lowest Imports in Senegal?
Keep it short and to the point. 3.90e+11. 